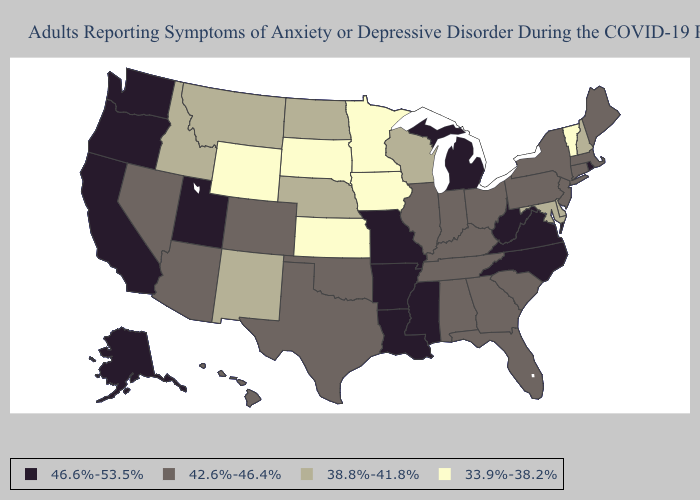Does Arizona have the lowest value in the West?
Answer briefly. No. Does Massachusetts have the lowest value in the USA?
Quick response, please. No. Does New Hampshire have the same value as New Mexico?
Be succinct. Yes. What is the highest value in the USA?
Write a very short answer. 46.6%-53.5%. Does Iowa have the lowest value in the MidWest?
Keep it brief. Yes. Does the map have missing data?
Keep it brief. No. Is the legend a continuous bar?
Short answer required. No. Name the states that have a value in the range 42.6%-46.4%?
Keep it brief. Alabama, Arizona, Colorado, Connecticut, Florida, Georgia, Hawaii, Illinois, Indiana, Kentucky, Maine, Massachusetts, Nevada, New Jersey, New York, Ohio, Oklahoma, Pennsylvania, South Carolina, Tennessee, Texas. Does South Carolina have a higher value than Vermont?
Keep it brief. Yes. What is the lowest value in states that border Missouri?
Keep it brief. 33.9%-38.2%. What is the value of Nebraska?
Concise answer only. 38.8%-41.8%. Among the states that border Iowa , does Missouri have the highest value?
Be succinct. Yes. Name the states that have a value in the range 38.8%-41.8%?
Short answer required. Delaware, Idaho, Maryland, Montana, Nebraska, New Hampshire, New Mexico, North Dakota, Wisconsin. Which states have the lowest value in the South?
Concise answer only. Delaware, Maryland. Among the states that border Alabama , does Mississippi have the lowest value?
Give a very brief answer. No. 